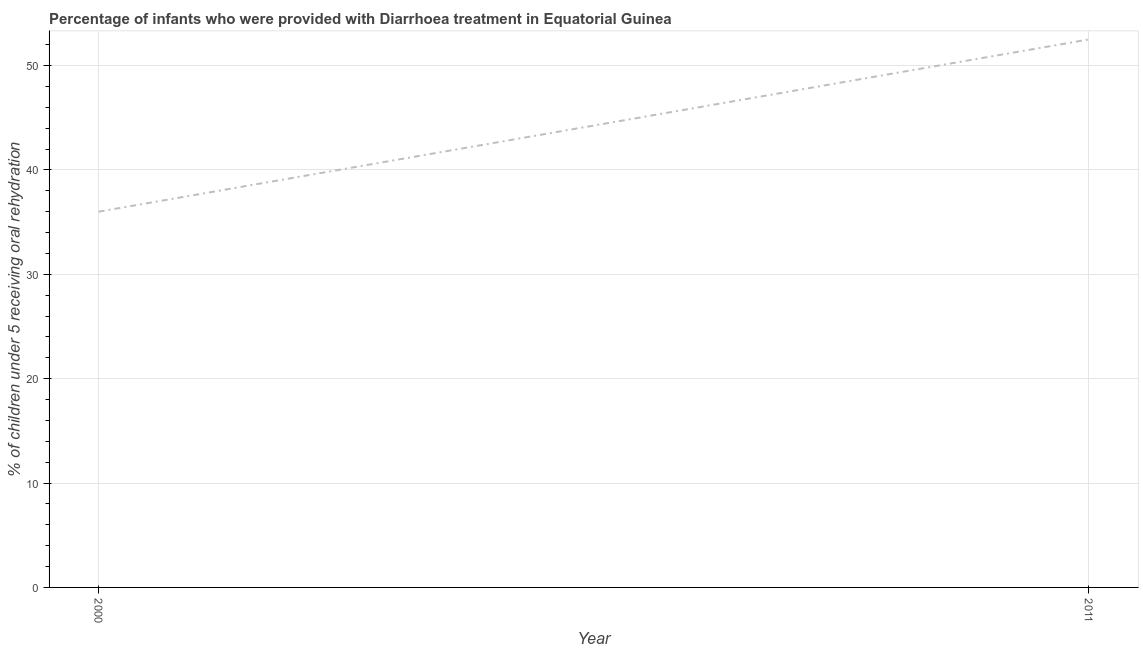What is the percentage of children who were provided with treatment diarrhoea in 2011?
Keep it short and to the point. 52.5. Across all years, what is the maximum percentage of children who were provided with treatment diarrhoea?
Keep it short and to the point. 52.5. Across all years, what is the minimum percentage of children who were provided with treatment diarrhoea?
Keep it short and to the point. 36. In which year was the percentage of children who were provided with treatment diarrhoea maximum?
Give a very brief answer. 2011. In which year was the percentage of children who were provided with treatment diarrhoea minimum?
Offer a very short reply. 2000. What is the sum of the percentage of children who were provided with treatment diarrhoea?
Ensure brevity in your answer.  88.5. What is the difference between the percentage of children who were provided with treatment diarrhoea in 2000 and 2011?
Offer a terse response. -16.5. What is the average percentage of children who were provided with treatment diarrhoea per year?
Your answer should be compact. 44.25. What is the median percentage of children who were provided with treatment diarrhoea?
Ensure brevity in your answer.  44.25. What is the ratio of the percentage of children who were provided with treatment diarrhoea in 2000 to that in 2011?
Your answer should be very brief. 0.69. Is the percentage of children who were provided with treatment diarrhoea in 2000 less than that in 2011?
Give a very brief answer. Yes. What is the title of the graph?
Give a very brief answer. Percentage of infants who were provided with Diarrhoea treatment in Equatorial Guinea. What is the label or title of the Y-axis?
Your answer should be very brief. % of children under 5 receiving oral rehydration. What is the % of children under 5 receiving oral rehydration in 2000?
Your answer should be very brief. 36. What is the % of children under 5 receiving oral rehydration of 2011?
Provide a short and direct response. 52.5. What is the difference between the % of children under 5 receiving oral rehydration in 2000 and 2011?
Your response must be concise. -16.5. What is the ratio of the % of children under 5 receiving oral rehydration in 2000 to that in 2011?
Provide a short and direct response. 0.69. 